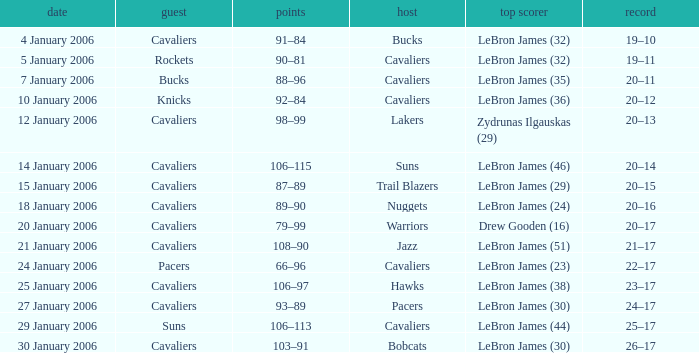Who was the leading score in the game at the Warriors? Drew Gooden (16). Could you help me parse every detail presented in this table? {'header': ['date', 'guest', 'points', 'host', 'top scorer', 'record'], 'rows': [['4 January 2006', 'Cavaliers', '91–84', 'Bucks', 'LeBron James (32)', '19–10'], ['5 January 2006', 'Rockets', '90–81', 'Cavaliers', 'LeBron James (32)', '19–11'], ['7 January 2006', 'Bucks', '88–96', 'Cavaliers', 'LeBron James (35)', '20–11'], ['10 January 2006', 'Knicks', '92–84', 'Cavaliers', 'LeBron James (36)', '20–12'], ['12 January 2006', 'Cavaliers', '98–99', 'Lakers', 'Zydrunas Ilgauskas (29)', '20–13'], ['14 January 2006', 'Cavaliers', '106–115', 'Suns', 'LeBron James (46)', '20–14'], ['15 January 2006', 'Cavaliers', '87–89', 'Trail Blazers', 'LeBron James (29)', '20–15'], ['18 January 2006', 'Cavaliers', '89–90', 'Nuggets', 'LeBron James (24)', '20–16'], ['20 January 2006', 'Cavaliers', '79–99', 'Warriors', 'Drew Gooden (16)', '20–17'], ['21 January 2006', 'Cavaliers', '108–90', 'Jazz', 'LeBron James (51)', '21–17'], ['24 January 2006', 'Pacers', '66–96', 'Cavaliers', 'LeBron James (23)', '22–17'], ['25 January 2006', 'Cavaliers', '106–97', 'Hawks', 'LeBron James (38)', '23–17'], ['27 January 2006', 'Cavaliers', '93–89', 'Pacers', 'LeBron James (30)', '24–17'], ['29 January 2006', 'Suns', '106–113', 'Cavaliers', 'LeBron James (44)', '25–17'], ['30 January 2006', 'Cavaliers', '103–91', 'Bobcats', 'LeBron James (30)', '26–17']]} 